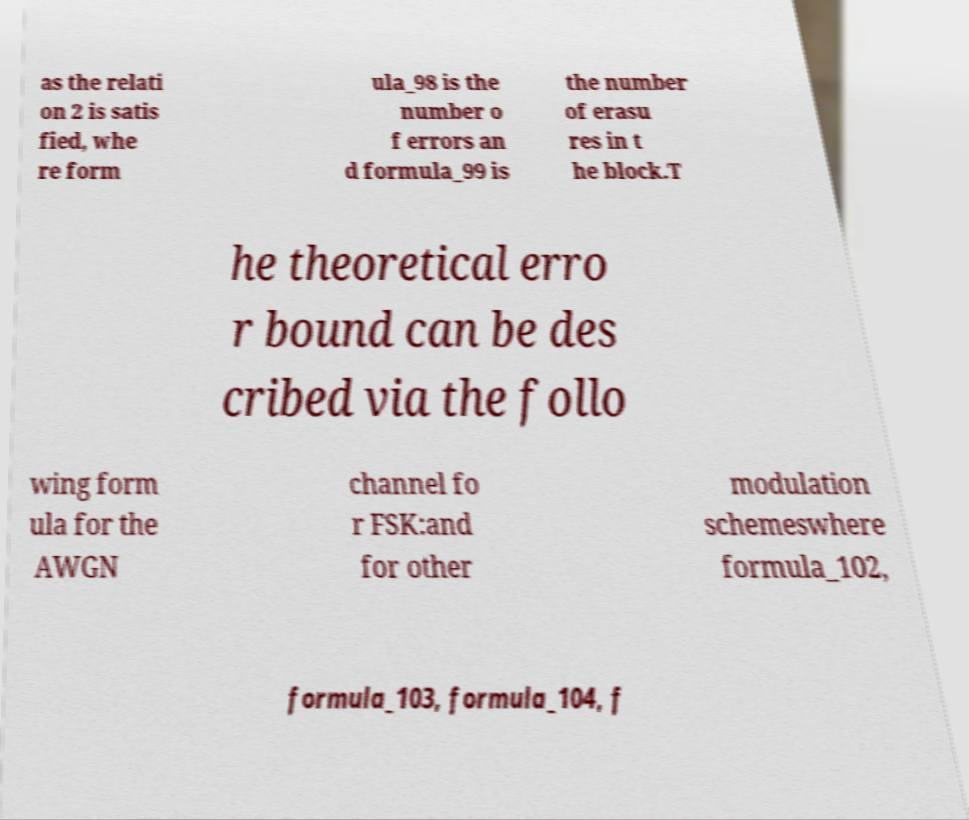Could you assist in decoding the text presented in this image and type it out clearly? as the relati on 2 is satis fied, whe re form ula_98 is the number o f errors an d formula_99 is the number of erasu res in t he block.T he theoretical erro r bound can be des cribed via the follo wing form ula for the AWGN channel fo r FSK:and for other modulation schemeswhere formula_102, formula_103, formula_104, f 